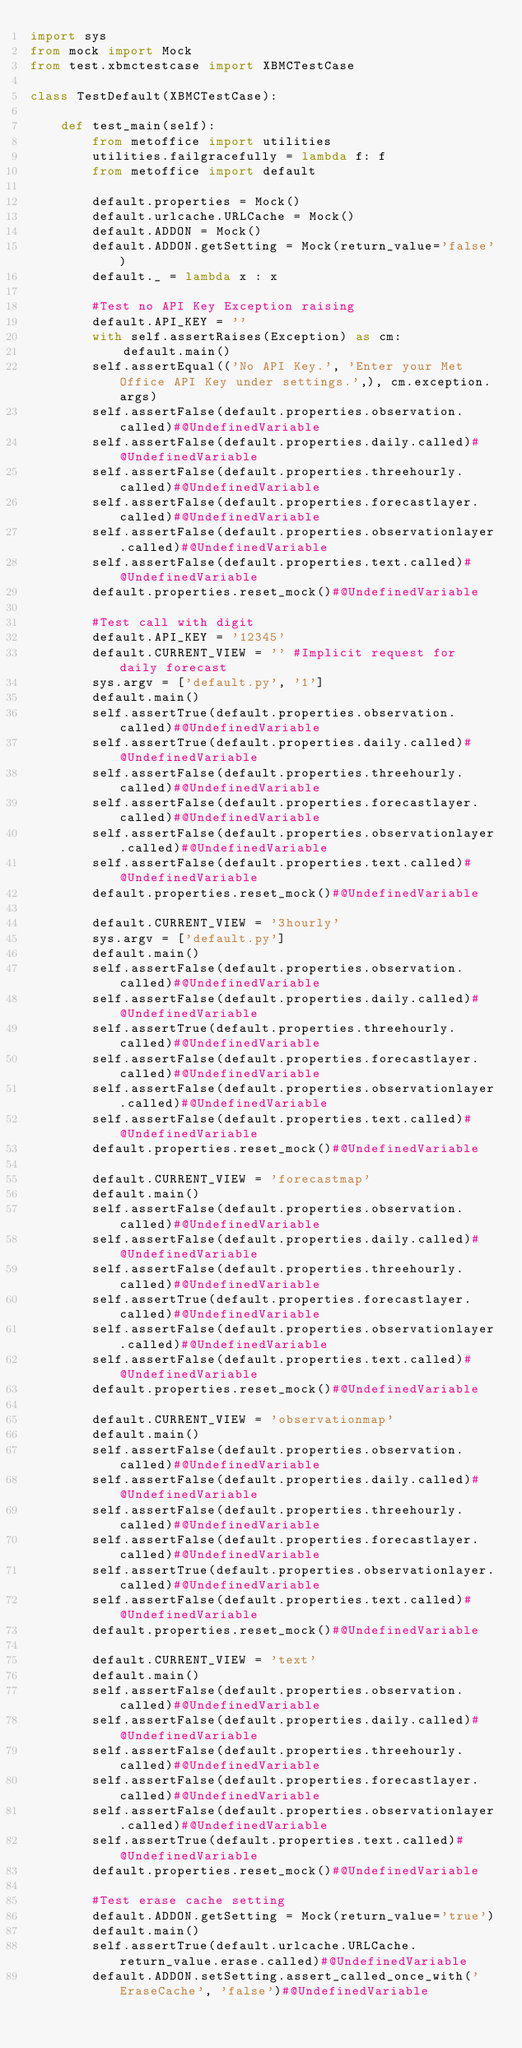<code> <loc_0><loc_0><loc_500><loc_500><_Python_>import sys
from mock import Mock
from test.xbmctestcase import XBMCTestCase

class TestDefault(XBMCTestCase):

    def test_main(self):
        from metoffice import utilities
        utilities.failgracefully = lambda f: f
        from metoffice import default
        
        default.properties = Mock()
        default.urlcache.URLCache = Mock()
        default.ADDON = Mock()
        default.ADDON.getSetting = Mock(return_value='false')
        default._ = lambda x : x

        #Test no API Key Exception raising
        default.API_KEY = ''
        with self.assertRaises(Exception) as cm:
            default.main()
        self.assertEqual(('No API Key.', 'Enter your Met Office API Key under settings.',), cm.exception.args)
        self.assertFalse(default.properties.observation.called)#@UndefinedVariable
        self.assertFalse(default.properties.daily.called)#@UndefinedVariable
        self.assertFalse(default.properties.threehourly.called)#@UndefinedVariable
        self.assertFalse(default.properties.forecastlayer.called)#@UndefinedVariable
        self.assertFalse(default.properties.observationlayer.called)#@UndefinedVariable
        self.assertFalse(default.properties.text.called)#@UndefinedVariable
        default.properties.reset_mock()#@UndefinedVariable

        #Test call with digit
        default.API_KEY = '12345'
        default.CURRENT_VIEW = '' #Implicit request for daily forecast
        sys.argv = ['default.py', '1']
        default.main()
        self.assertTrue(default.properties.observation.called)#@UndefinedVariable
        self.assertTrue(default.properties.daily.called)#@UndefinedVariable
        self.assertFalse(default.properties.threehourly.called)#@UndefinedVariable
        self.assertFalse(default.properties.forecastlayer.called)#@UndefinedVariable
        self.assertFalse(default.properties.observationlayer.called)#@UndefinedVariable
        self.assertFalse(default.properties.text.called)#@UndefinedVariable
        default.properties.reset_mock()#@UndefinedVariable

        default.CURRENT_VIEW = '3hourly'
        sys.argv = ['default.py']
        default.main()
        self.assertFalse(default.properties.observation.called)#@UndefinedVariable
        self.assertFalse(default.properties.daily.called)#@UndefinedVariable
        self.assertTrue(default.properties.threehourly.called)#@UndefinedVariable
        self.assertFalse(default.properties.forecastlayer.called)#@UndefinedVariable
        self.assertFalse(default.properties.observationlayer.called)#@UndefinedVariable
        self.assertFalse(default.properties.text.called)#@UndefinedVariable
        default.properties.reset_mock()#@UndefinedVariable

        default.CURRENT_VIEW = 'forecastmap'
        default.main()
        self.assertFalse(default.properties.observation.called)#@UndefinedVariable
        self.assertFalse(default.properties.daily.called)#@UndefinedVariable
        self.assertFalse(default.properties.threehourly.called)#@UndefinedVariable
        self.assertTrue(default.properties.forecastlayer.called)#@UndefinedVariable
        self.assertFalse(default.properties.observationlayer.called)#@UndefinedVariable
        self.assertFalse(default.properties.text.called)#@UndefinedVariable
        default.properties.reset_mock()#@UndefinedVariable

        default.CURRENT_VIEW = 'observationmap'
        default.main()
        self.assertFalse(default.properties.observation.called)#@UndefinedVariable
        self.assertFalse(default.properties.daily.called)#@UndefinedVariable
        self.assertFalse(default.properties.threehourly.called)#@UndefinedVariable
        self.assertFalse(default.properties.forecastlayer.called)#@UndefinedVariable
        self.assertTrue(default.properties.observationlayer.called)#@UndefinedVariable
        self.assertFalse(default.properties.text.called)#@UndefinedVariable
        default.properties.reset_mock()#@UndefinedVariable

        default.CURRENT_VIEW = 'text'
        default.main()
        self.assertFalse(default.properties.observation.called)#@UndefinedVariable
        self.assertFalse(default.properties.daily.called)#@UndefinedVariable
        self.assertFalse(default.properties.threehourly.called)#@UndefinedVariable
        self.assertFalse(default.properties.forecastlayer.called)#@UndefinedVariable
        self.assertFalse(default.properties.observationlayer.called)#@UndefinedVariable
        self.assertTrue(default.properties.text.called)#@UndefinedVariable
        default.properties.reset_mock()#@UndefinedVariable

        #Test erase cache setting
        default.ADDON.getSetting = Mock(return_value='true')
        default.main()
        self.assertTrue(default.urlcache.URLCache.return_value.erase.called)#@UndefinedVariable
        default.ADDON.setSetting.assert_called_once_with('EraseCache', 'false')#@UndefinedVariable
        </code> 